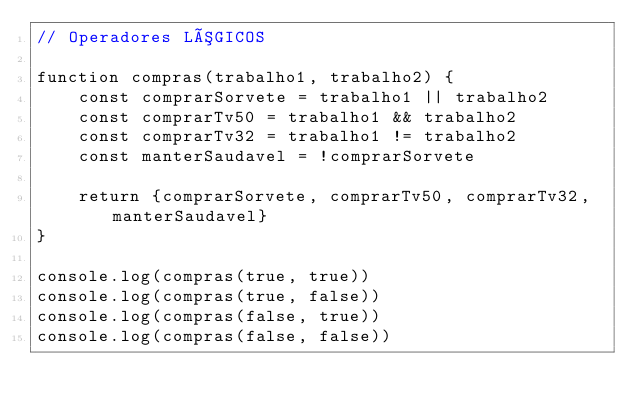<code> <loc_0><loc_0><loc_500><loc_500><_JavaScript_>// Operadores LÓGICOS

function compras(trabalho1, trabalho2) {
    const comprarSorvete = trabalho1 || trabalho2
    const comprarTv50 = trabalho1 && trabalho2
    const comprarTv32 = trabalho1 != trabalho2
    const manterSaudavel = !comprarSorvete
    
    return {comprarSorvete, comprarTv50, comprarTv32, manterSaudavel}
}

console.log(compras(true, true))
console.log(compras(true, false))
console.log(compras(false, true))
console.log(compras(false, false))</code> 